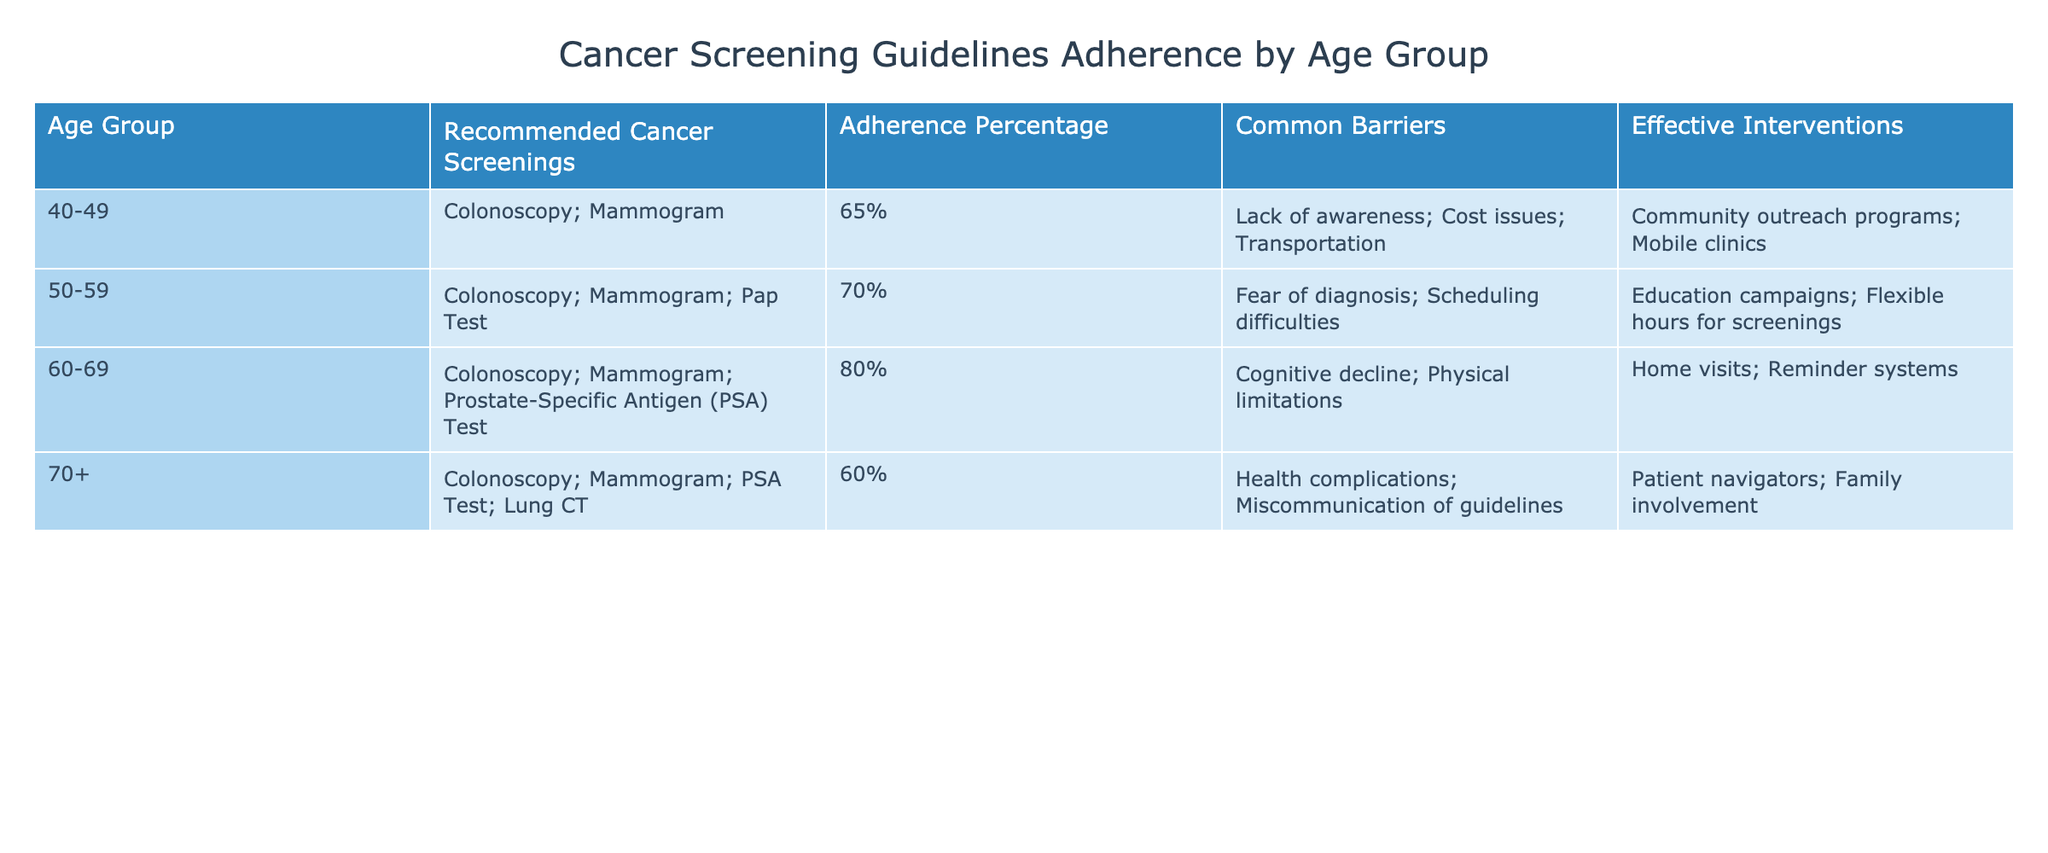What age group has the highest adherence percentage for cancer screenings? The table shows the adherence percentages for each age group. The highest adherence percentage is listed for the age group 60-69, with an adherence percentage of 80%.
Answer: 60-69 What are the common barriers for the 70+ age group regarding cancer screenings? The table specifies common barriers for each age group. For the 70+ age group, the common barriers are health complications and miscommunication of guidelines.
Answer: Health complications; Miscommunication of guidelines What is the difference in adherence percentage between the 50-59 age group and the 70+ age group? The adherence percentage for the 50-59 age group is 70% and for the 70+ age group is 60%. Calculating the difference: 70% - 60% = 10%.
Answer: 10% Are the recommended cancer screenings the same for all age groups? By examining the table, we see that the recommended screenings vary by age group. Therefore, the answer is no, they are not the same.
Answer: No What interventions were listed for the 60-69 age group? The table contains a specific column for effective interventions by age group. For the 60-69 age group, the effective interventions are home visits and reminder systems.
Answer: Home visits; Reminder systems What age group has the least adherence percentage and what barriers are associated with it? The least adherence percentage in the table is for the 70+ age group at 60%. The associated barriers are health complications and miscommunication of guidelines.
Answer: 70+, Health complications; Miscommunication of guidelines What is the average adherence percentage across all age groups? We first list the adherence percentages: 65%, 70%, 80%, 60%. Then calculate the average: (65 + 70 + 80 + 60) / 4 = 68.75%.
Answer: 68.75% Which age group has the most recommended cancer screenings? By reviewing the table, we find that the 70+ age group has the most recommended screenings, which include colonoscopy, mammogram, PSA test, and lung CT — a total of four screenings.
Answer: 70+ What is the primary common barrier for the 50-59 age group? The table indicates that fear of diagnosis and scheduling difficulties are common barriers for this age group. The primary one mentioned first is fear of diagnosis.
Answer: Fear of diagnosis 